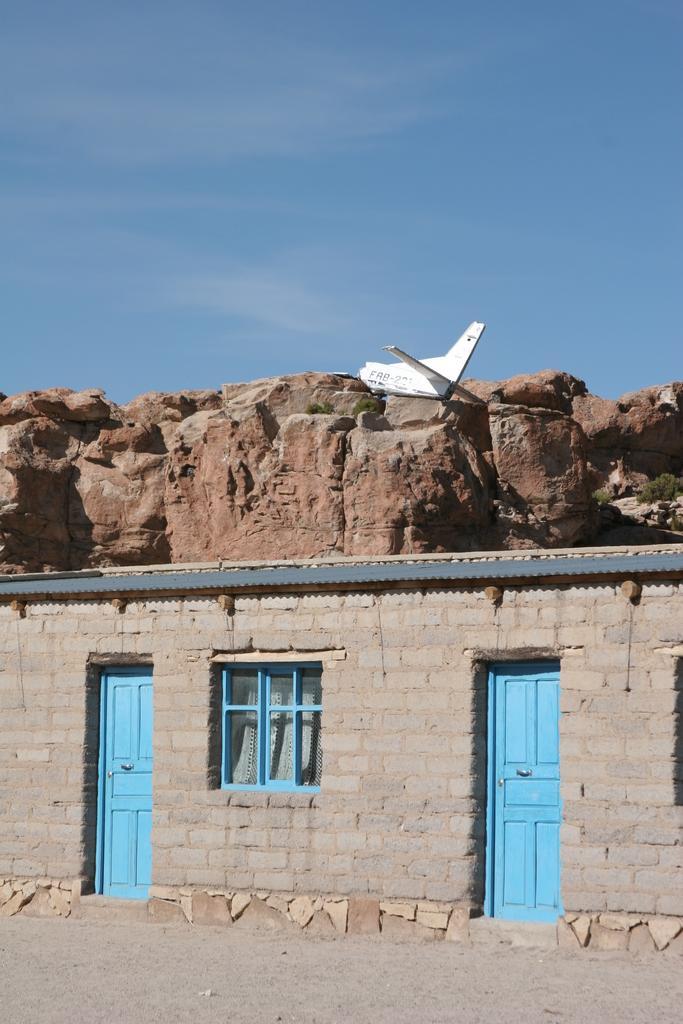How would you summarize this image in a sentence or two? This picture might be taken from outside of the house. In this image, we can see two doors, window. In the background, we can see some rocks, airplane. At the top, we can see a sky, at the bottom there is a land with some stones. 